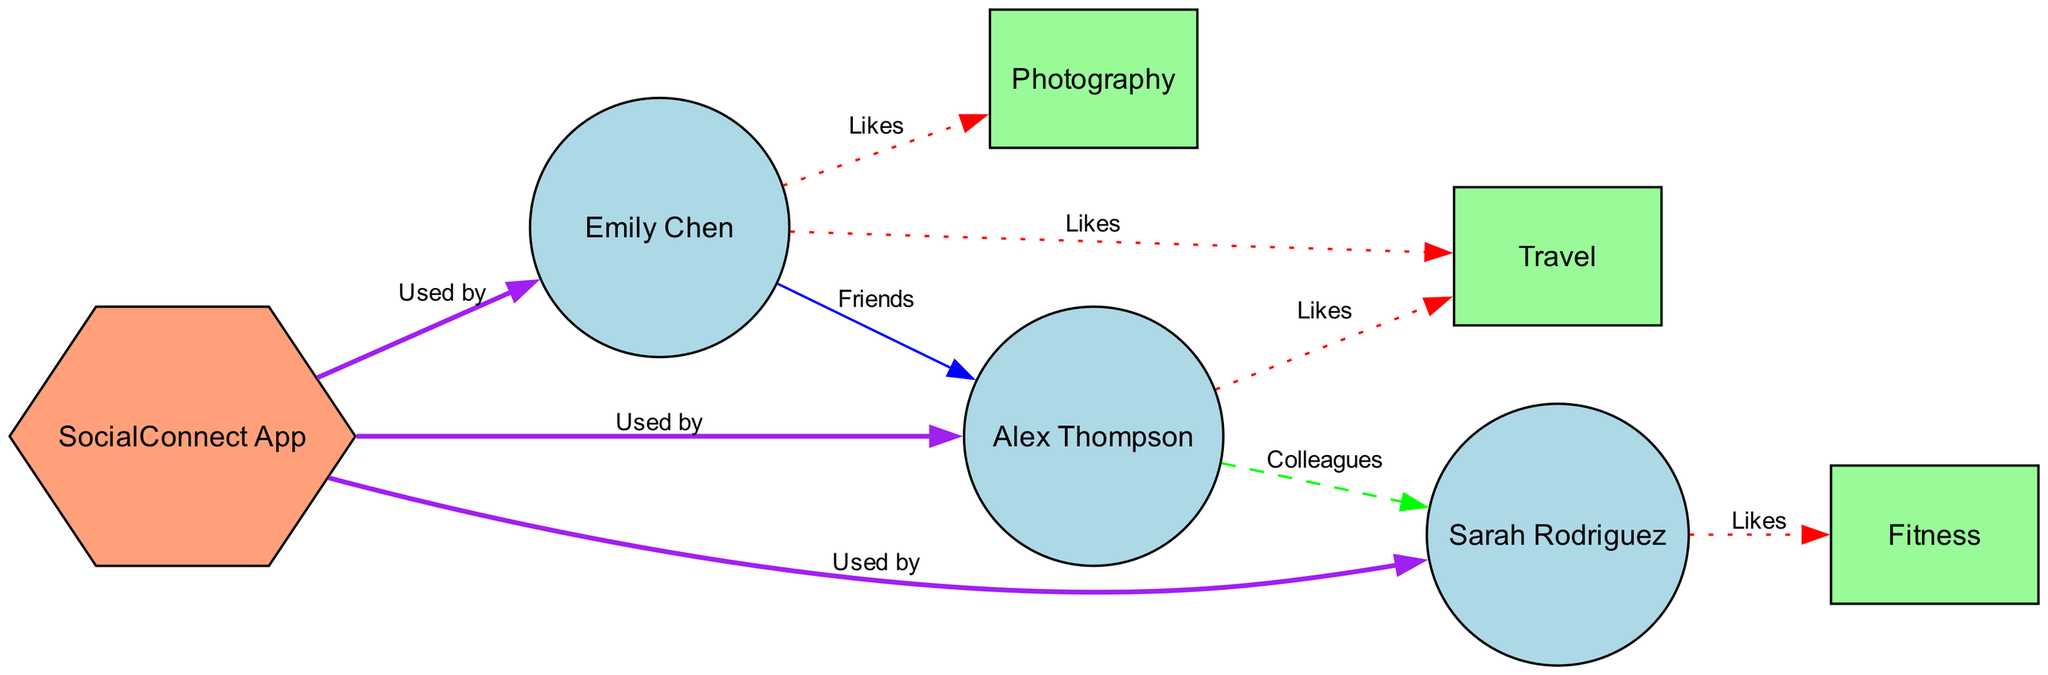What are the names of the users in the diagram? The diagram shows three users: Emily Chen, Alex Thompson, and Sarah Rodriguez.
Answer: Emily Chen, Alex Thompson, Sarah Rodriguez How many interests are represented in the diagram? The diagram contains three interests: Photography, Travel, and Fitness.
Answer: 3 What is the relationship between Emily Chen and Alex Thompson? According to the diagram, Emily Chen and Alex Thompson are labeled as Friends, which indicates a friendly relationship.
Answer: Friends Which user likes Photography? The connection from Emily Chen to Photography shows that she likes this interest, as indicated by the "Likes" relationship.
Answer: Emily Chen How many users are using the SocialConnect App? The edges leading from the SocialConnect App to each of the three users indicate that all users are utilizing the application.
Answer: 3 Which two users have a colleague relationship? The diagram identifies Alex Thompson and Sarah Rodriguez as colleagues, connected through a dashed line labeled "Colleagues."
Answer: Alex Thompson, Sarah Rodriguez What color is used for the "Likes" relationships in the diagram? The edges labeled "Likes" are represented in red, as specified in the edge styling of the diagram.
Answer: Red Name the interests liked by Emily Chen. Emily Chen has connections to Photography and Travel, indicating that she likes both interests.
Answer: Photography, Travel Which user is connected to the Fitness interest? Sarah Rodriguez is connected to the Fitness interest by a red dotted line labeled "Likes," signifying her preference for it.
Answer: Sarah Rodriguez 